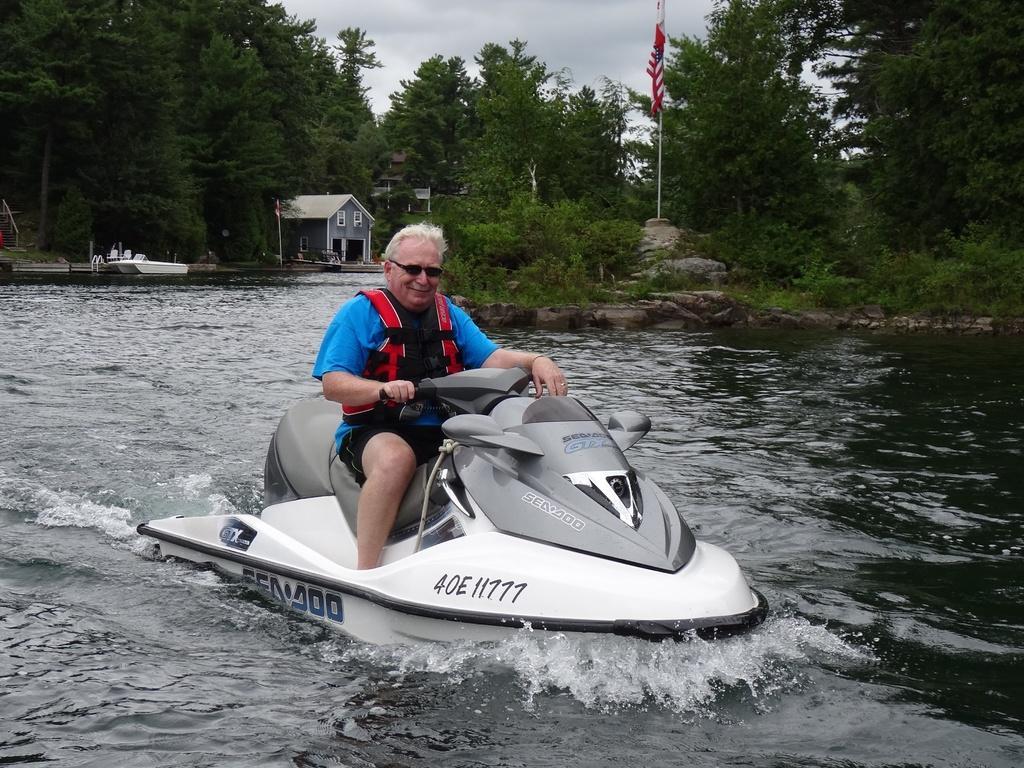How would you summarize this image in a sentence or two? There is a person in blue color t-shirt, sitting on the seat of boat and driving this boat on the water of river. In the background, there is another boat on the water, there are plants, trees, a house and there are clouds in the sky. 